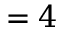Convert formula to latex. <formula><loc_0><loc_0><loc_500><loc_500>= 4</formula> 